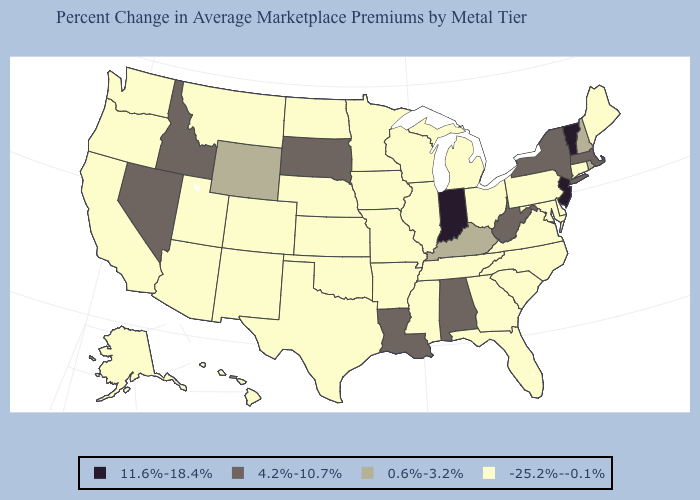What is the highest value in states that border New Mexico?
Write a very short answer. -25.2%--0.1%. Name the states that have a value in the range -25.2%--0.1%?
Concise answer only. Alaska, Arizona, Arkansas, California, Colorado, Connecticut, Delaware, Florida, Georgia, Hawaii, Illinois, Iowa, Kansas, Maine, Maryland, Michigan, Minnesota, Mississippi, Missouri, Montana, Nebraska, New Mexico, North Carolina, North Dakota, Ohio, Oklahoma, Oregon, Pennsylvania, South Carolina, Tennessee, Texas, Utah, Virginia, Washington, Wisconsin. What is the value of Nevada?
Give a very brief answer. 4.2%-10.7%. Does New York have the highest value in the USA?
Keep it brief. No. What is the value of Maryland?
Short answer required. -25.2%--0.1%. What is the value of Alabama?
Answer briefly. 4.2%-10.7%. Does California have the highest value in the USA?
Give a very brief answer. No. Does Florida have a lower value than Arizona?
Write a very short answer. No. Among the states that border Washington , does Idaho have the lowest value?
Concise answer only. No. How many symbols are there in the legend?
Short answer required. 4. Does Texas have a higher value than Arkansas?
Be succinct. No. Does the map have missing data?
Answer briefly. No. What is the highest value in states that border Kentucky?
Be succinct. 11.6%-18.4%. Name the states that have a value in the range -25.2%--0.1%?
Concise answer only. Alaska, Arizona, Arkansas, California, Colorado, Connecticut, Delaware, Florida, Georgia, Hawaii, Illinois, Iowa, Kansas, Maine, Maryland, Michigan, Minnesota, Mississippi, Missouri, Montana, Nebraska, New Mexico, North Carolina, North Dakota, Ohio, Oklahoma, Oregon, Pennsylvania, South Carolina, Tennessee, Texas, Utah, Virginia, Washington, Wisconsin. 